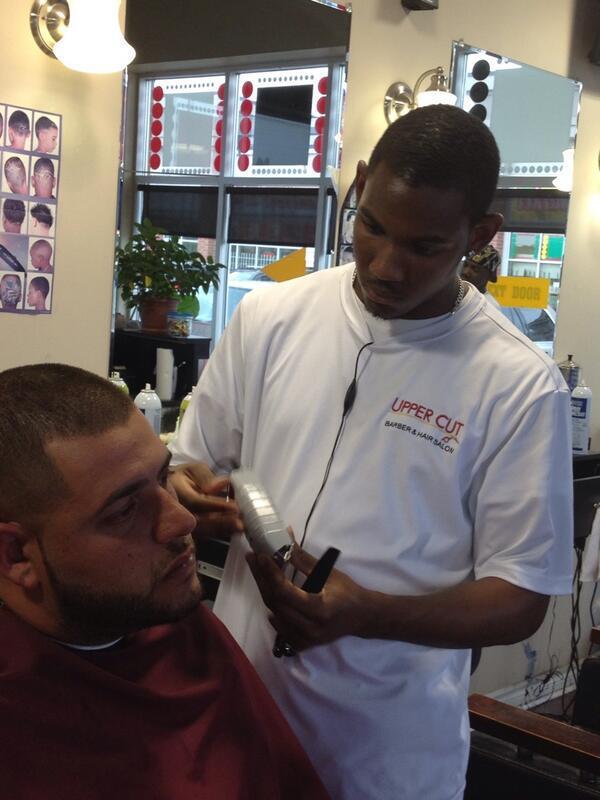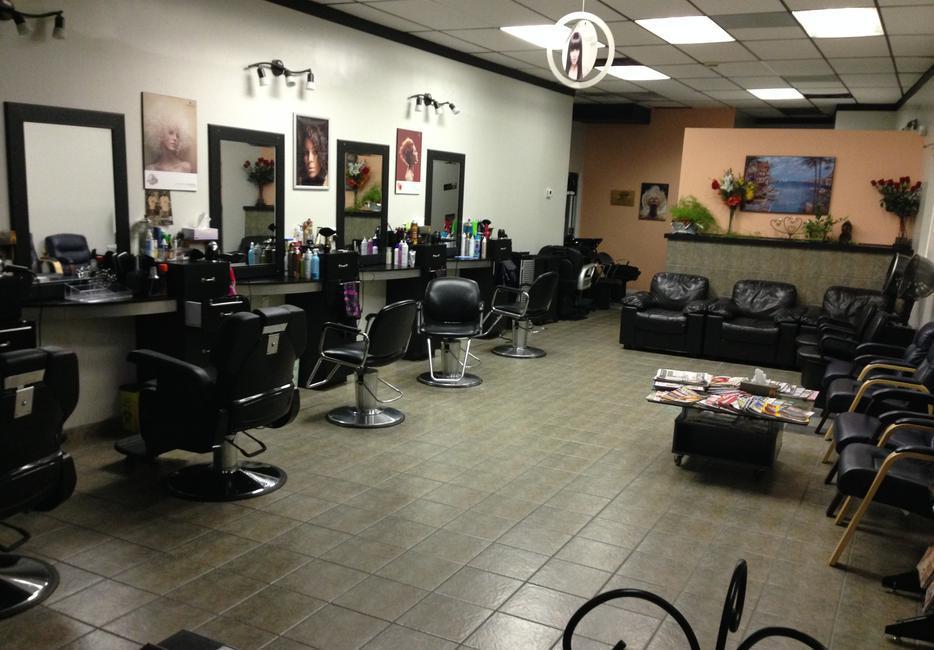The first image is the image on the left, the second image is the image on the right. Assess this claim about the two images: "THere are exactly two people in the image on the left.". Correct or not? Answer yes or no. Yes. 